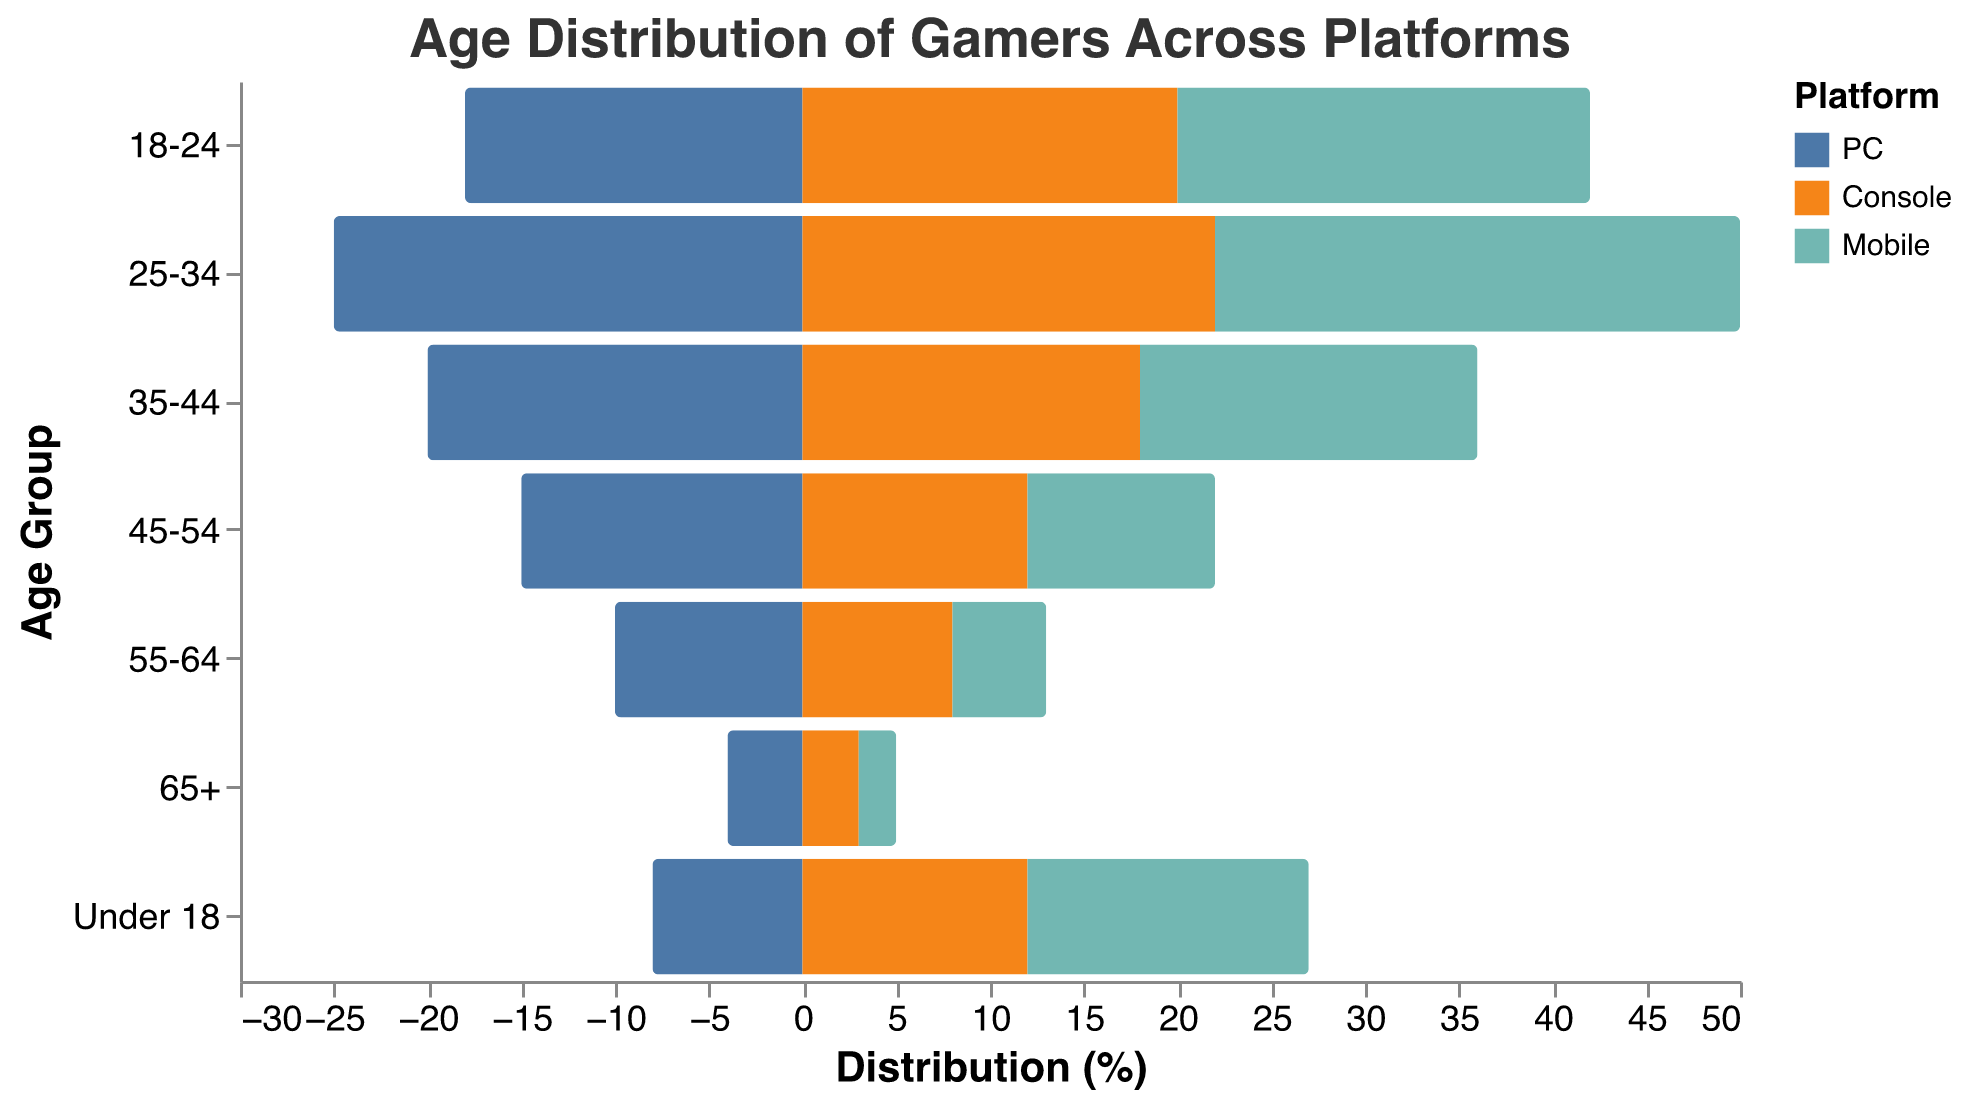What is the title of the figure? The title is displayed at the top of the figure and it reads "Age Distribution of Gamers Across Platforms".
Answer: Age Distribution of Gamers Across Platforms What age group has the highest percentage of mobile gamers? The highest bar on the mobile side of the population pyramid indicates the age group with the highest percentage.
Answer: 25-34 How many age groups have more Mobile gamers compared to Console gamers? Compare the heights of the bars for Mobile and Console categories across all age groups. There are 5 such groups: Under 18, 18-24, 25-34, 35-44, and 55-64.
Answer: 5 Which platform has the highest percentage of gamers aged 55-64? Compare the values for the 55-64 age group across all platforms. The tallest bar within this age group represents the platform with the highest percentage.
Answer: PC In the age group 35-44, which platform sees the least percentage of gamers? Look for the smallest bar in the 35-44 age group. The smallest bar belongs to the Mobile platform.
Answer: Mobile What is the difference in the percentage of gamers aged 25-34 between PC and Mobile? Identify the bars for PC and Mobile within the 25-34 age group. The values are 25% for PC and 28% for Mobile. The difference is 28 - 25.
Answer: 3 Across all age groups, which platform appears to attract younger gamers the most? Observe the younger age groups (Under 18, 18-24, 25-34) and note which platform consistently has higher bars. Mobile has the highest bars for Under 18, 18-24, and 25-34.
Answer: Mobile What is the average percentage of console gamers across all age groups? Sum the console percentages for each age group and divide by the number of age groups: (12 + 20 + 22 + 18 + 12 + 8 + 3) / 7 = 95 / 7.
Answer: 13.57 Comparing PC and Console platforms, which one has a higher percentage of gamers aged Under 18? Compare the heights of the bars for the Under 18 age group for both PC and Console categories. Console has a higher value (12%) compared to PC (8%).
Answer: Console What is the total percentage of gamers aged 45+ for the PC platform? Sum the percentages for the age groups 45-54, 55-64, and 65+ for the PC platform: 15 + 10 + 4 = 29.
Answer: 29 